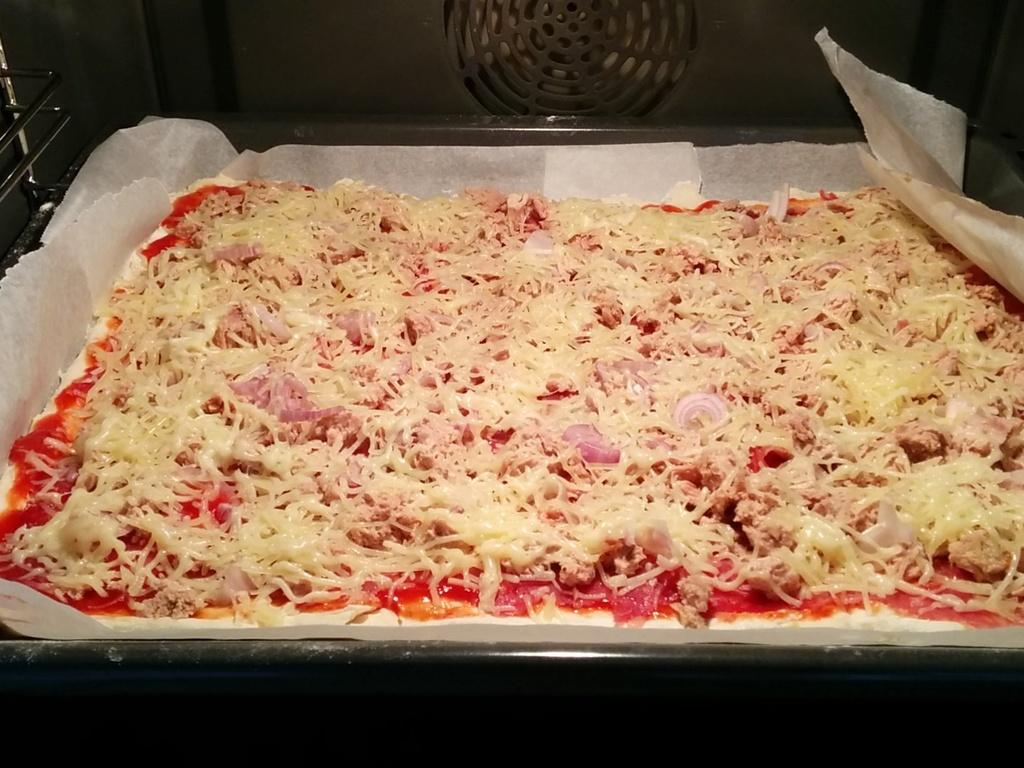What object is present in the image that can hold items? There is a tray in the image that can hold items. What is on the tray in the image? There is food and a paper on the tray in the image. What type of stone is used to power the journey of the food on the tray in the image? There is no stone or journey of the food mentioned in the image; it simply shows food and a paper on a tray. 